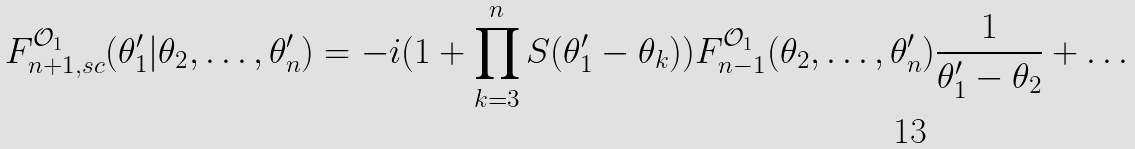Convert formula to latex. <formula><loc_0><loc_0><loc_500><loc_500>F _ { n + 1 , s c } ^ { \mathcal { O } _ { 1 } } ( \theta ^ { \prime } _ { 1 } | \theta _ { 2 } , \dots , \theta ^ { \prime } _ { n } ) = - i ( 1 + \prod _ { k = 3 } ^ { n } S ( \theta ^ { \prime } _ { 1 } - \theta _ { k } ) ) F _ { n - 1 } ^ { \mathcal { O } _ { 1 } } ( \theta _ { 2 } , \dots , \theta ^ { \prime } _ { n } ) \frac { 1 } { \theta ^ { \prime } _ { 1 } - \theta _ { 2 } } + \dots</formula> 